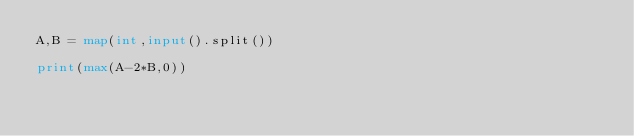<code> <loc_0><loc_0><loc_500><loc_500><_Python_>A,B = map(int,input().split())

print(max(A-2*B,0))</code> 